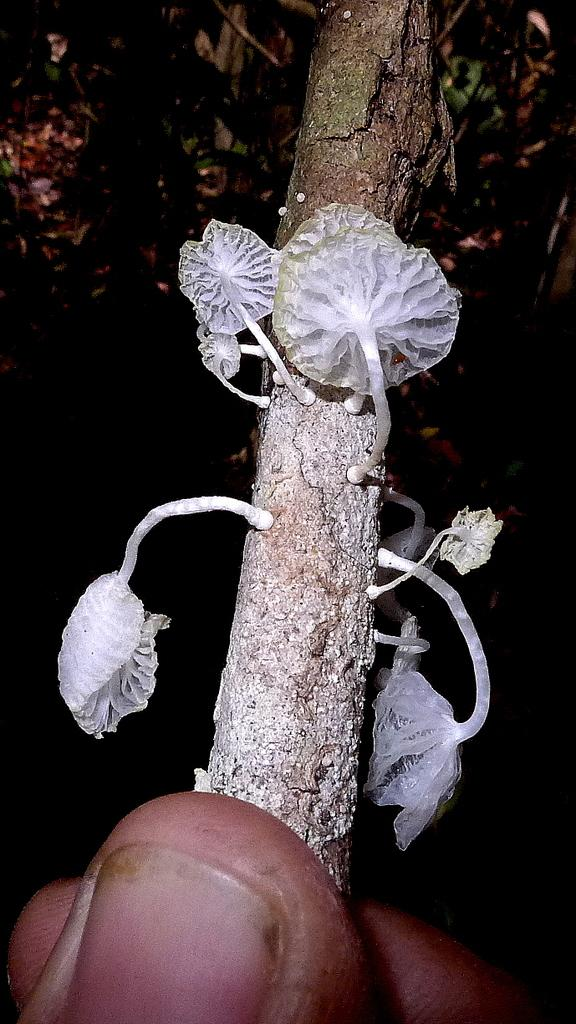What is the main subject of the image? There is a person in the image. What is the person holding in their hand? The person is holding a stem with their hand. What can be seen on the stem? There are white color objects on the stem. How many boys are expressing regret in the image? There are no boys or expressions of regret present in the image. 